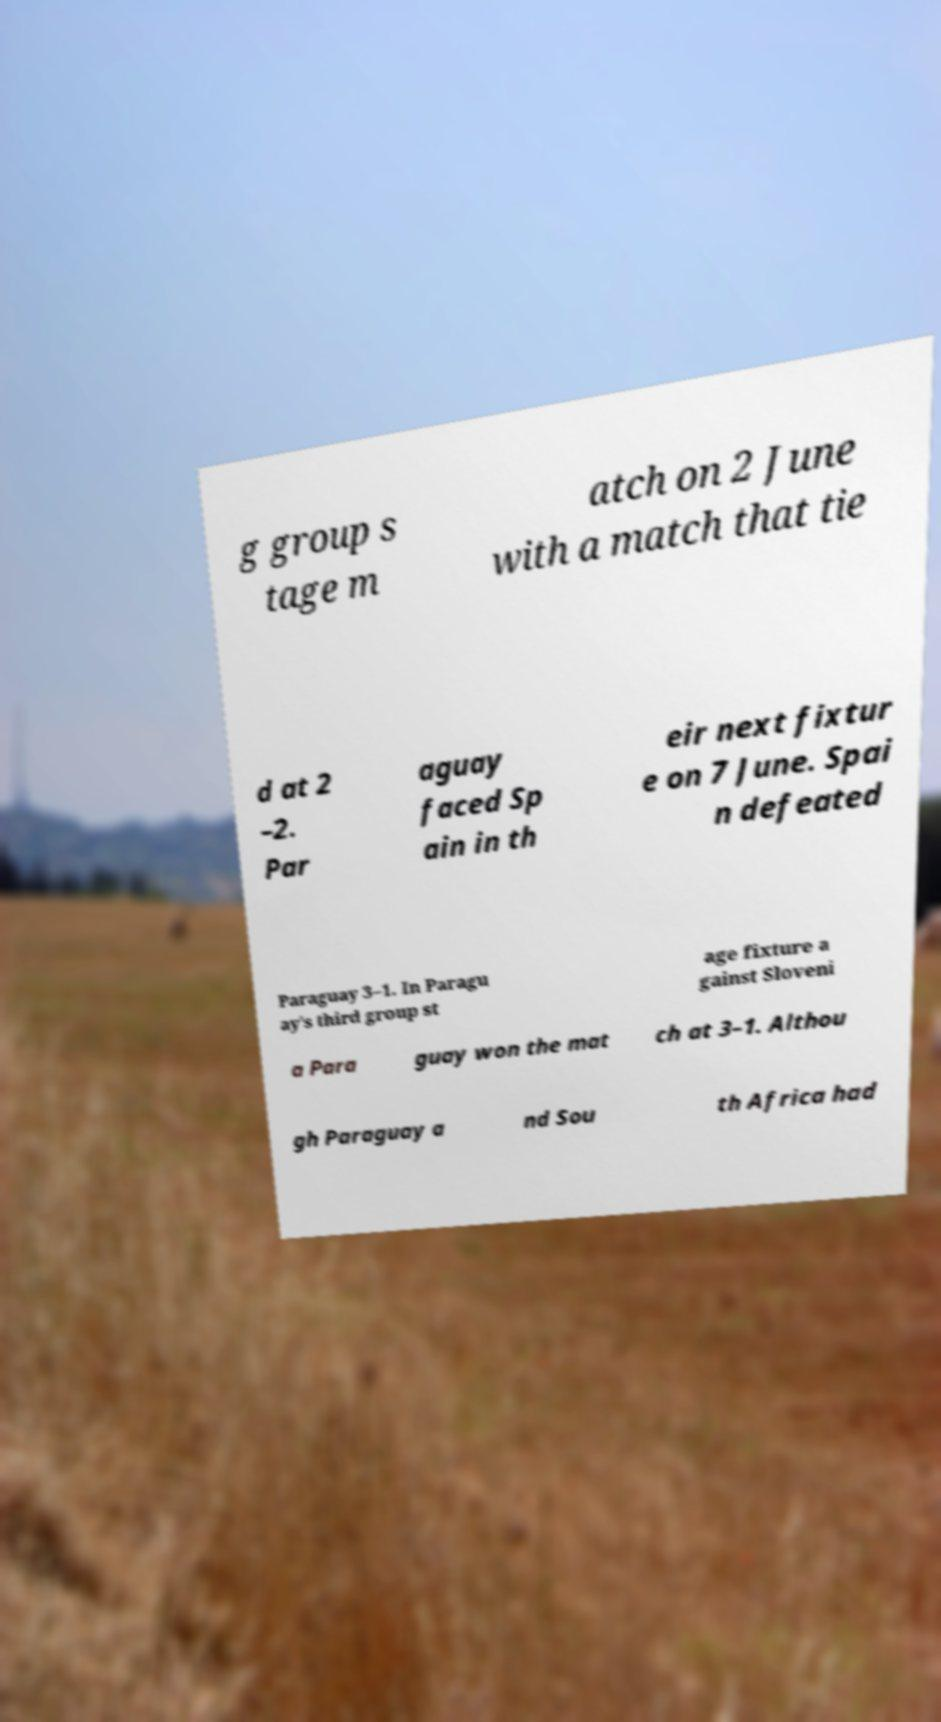I need the written content from this picture converted into text. Can you do that? g group s tage m atch on 2 June with a match that tie d at 2 –2. Par aguay faced Sp ain in th eir next fixtur e on 7 June. Spai n defeated Paraguay 3–1. In Paragu ay's third group st age fixture a gainst Sloveni a Para guay won the mat ch at 3–1. Althou gh Paraguay a nd Sou th Africa had 